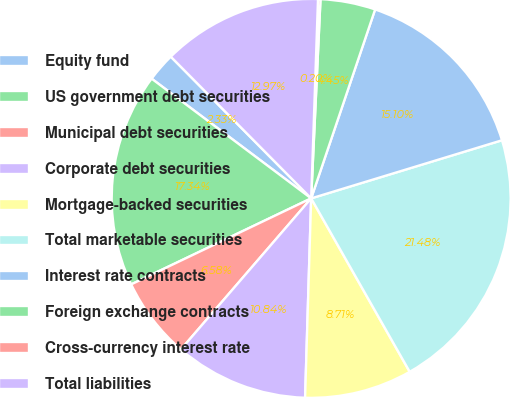<chart> <loc_0><loc_0><loc_500><loc_500><pie_chart><fcel>Equity fund<fcel>US government debt securities<fcel>Municipal debt securities<fcel>Corporate debt securities<fcel>Mortgage-backed securities<fcel>Total marketable securities<fcel>Interest rate contracts<fcel>Foreign exchange contracts<fcel>Cross-currency interest rate<fcel>Total liabilities<nl><fcel>2.33%<fcel>17.34%<fcel>6.58%<fcel>10.84%<fcel>8.71%<fcel>21.48%<fcel>15.1%<fcel>4.45%<fcel>0.2%<fcel>12.97%<nl></chart> 